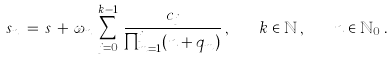Convert formula to latex. <formula><loc_0><loc_0><loc_500><loc_500>s _ { n } \, = \, s \, + \, \omega _ { n } \, \sum _ { j = 0 } ^ { k - 1 } \, \frac { c _ { j } } { \prod _ { m = 1 } ^ { j } ( n + q _ { m } ) } \, , \quad k \in \mathbb { N } \, , \quad n \in \mathbb { N } _ { 0 } \, .</formula> 